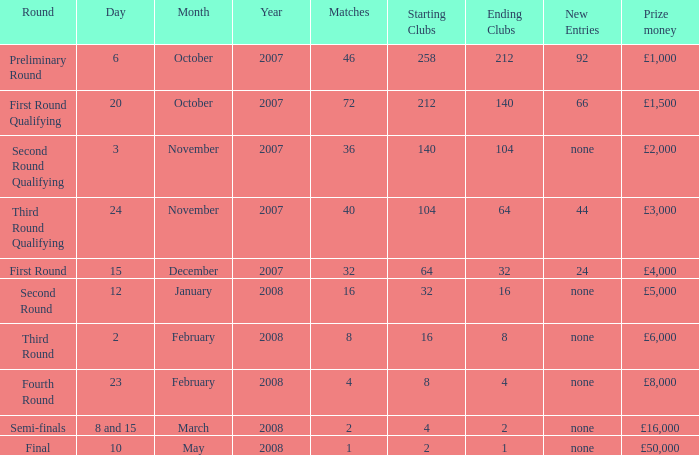What is the average for matches with a prize money amount of £3,000? 40.0. 